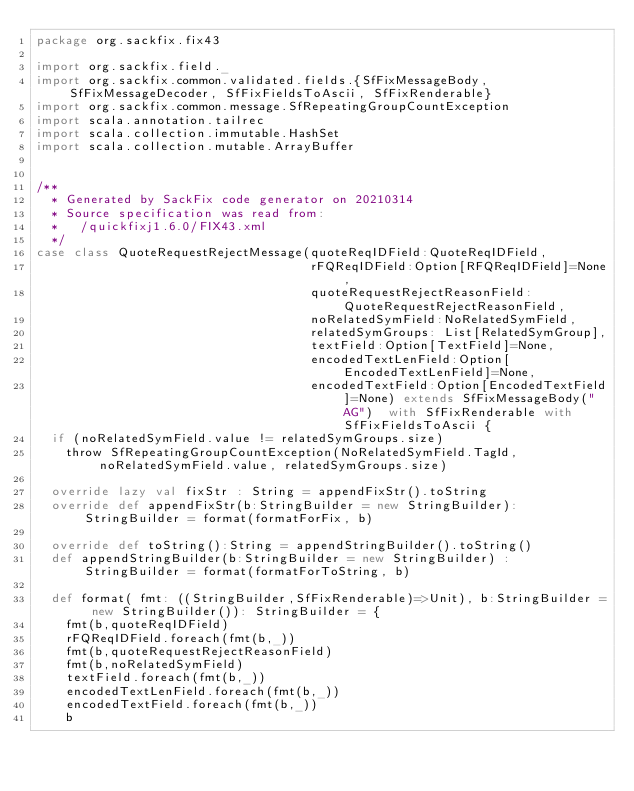<code> <loc_0><loc_0><loc_500><loc_500><_Scala_>package org.sackfix.fix43

import org.sackfix.field._
import org.sackfix.common.validated.fields.{SfFixMessageBody, SfFixMessageDecoder, SfFixFieldsToAscii, SfFixRenderable}
import org.sackfix.common.message.SfRepeatingGroupCountException
import scala.annotation.tailrec
import scala.collection.immutable.HashSet
import scala.collection.mutable.ArrayBuffer


/**
  * Generated by SackFix code generator on 20210314
  * Source specification was read from:
  *   /quickfixj1.6.0/FIX43.xml
  */
case class QuoteRequestRejectMessage(quoteReqIDField:QuoteReqIDField,
                                     rFQReqIDField:Option[RFQReqIDField]=None,
                                     quoteRequestRejectReasonField:QuoteRequestRejectReasonField,
                                     noRelatedSymField:NoRelatedSymField,
                                     relatedSymGroups: List[RelatedSymGroup],
                                     textField:Option[TextField]=None,
                                     encodedTextLenField:Option[EncodedTextLenField]=None,
                                     encodedTextField:Option[EncodedTextField]=None) extends SfFixMessageBody("AG")  with SfFixRenderable with SfFixFieldsToAscii {
  if (noRelatedSymField.value != relatedSymGroups.size)
    throw SfRepeatingGroupCountException(NoRelatedSymField.TagId,noRelatedSymField.value, relatedSymGroups.size)

  override lazy val fixStr : String = appendFixStr().toString
  override def appendFixStr(b:StringBuilder = new StringBuilder): StringBuilder = format(formatForFix, b)

  override def toString():String = appendStringBuilder().toString()
  def appendStringBuilder(b:StringBuilder = new StringBuilder) : StringBuilder = format(formatForToString, b)

  def format( fmt: ((StringBuilder,SfFixRenderable)=>Unit), b:StringBuilder = new StringBuilder()): StringBuilder = {
    fmt(b,quoteReqIDField)
    rFQReqIDField.foreach(fmt(b,_))
    fmt(b,quoteRequestRejectReasonField)
    fmt(b,noRelatedSymField)
    textField.foreach(fmt(b,_))
    encodedTextLenField.foreach(fmt(b,_))
    encodedTextField.foreach(fmt(b,_))
    b</code> 